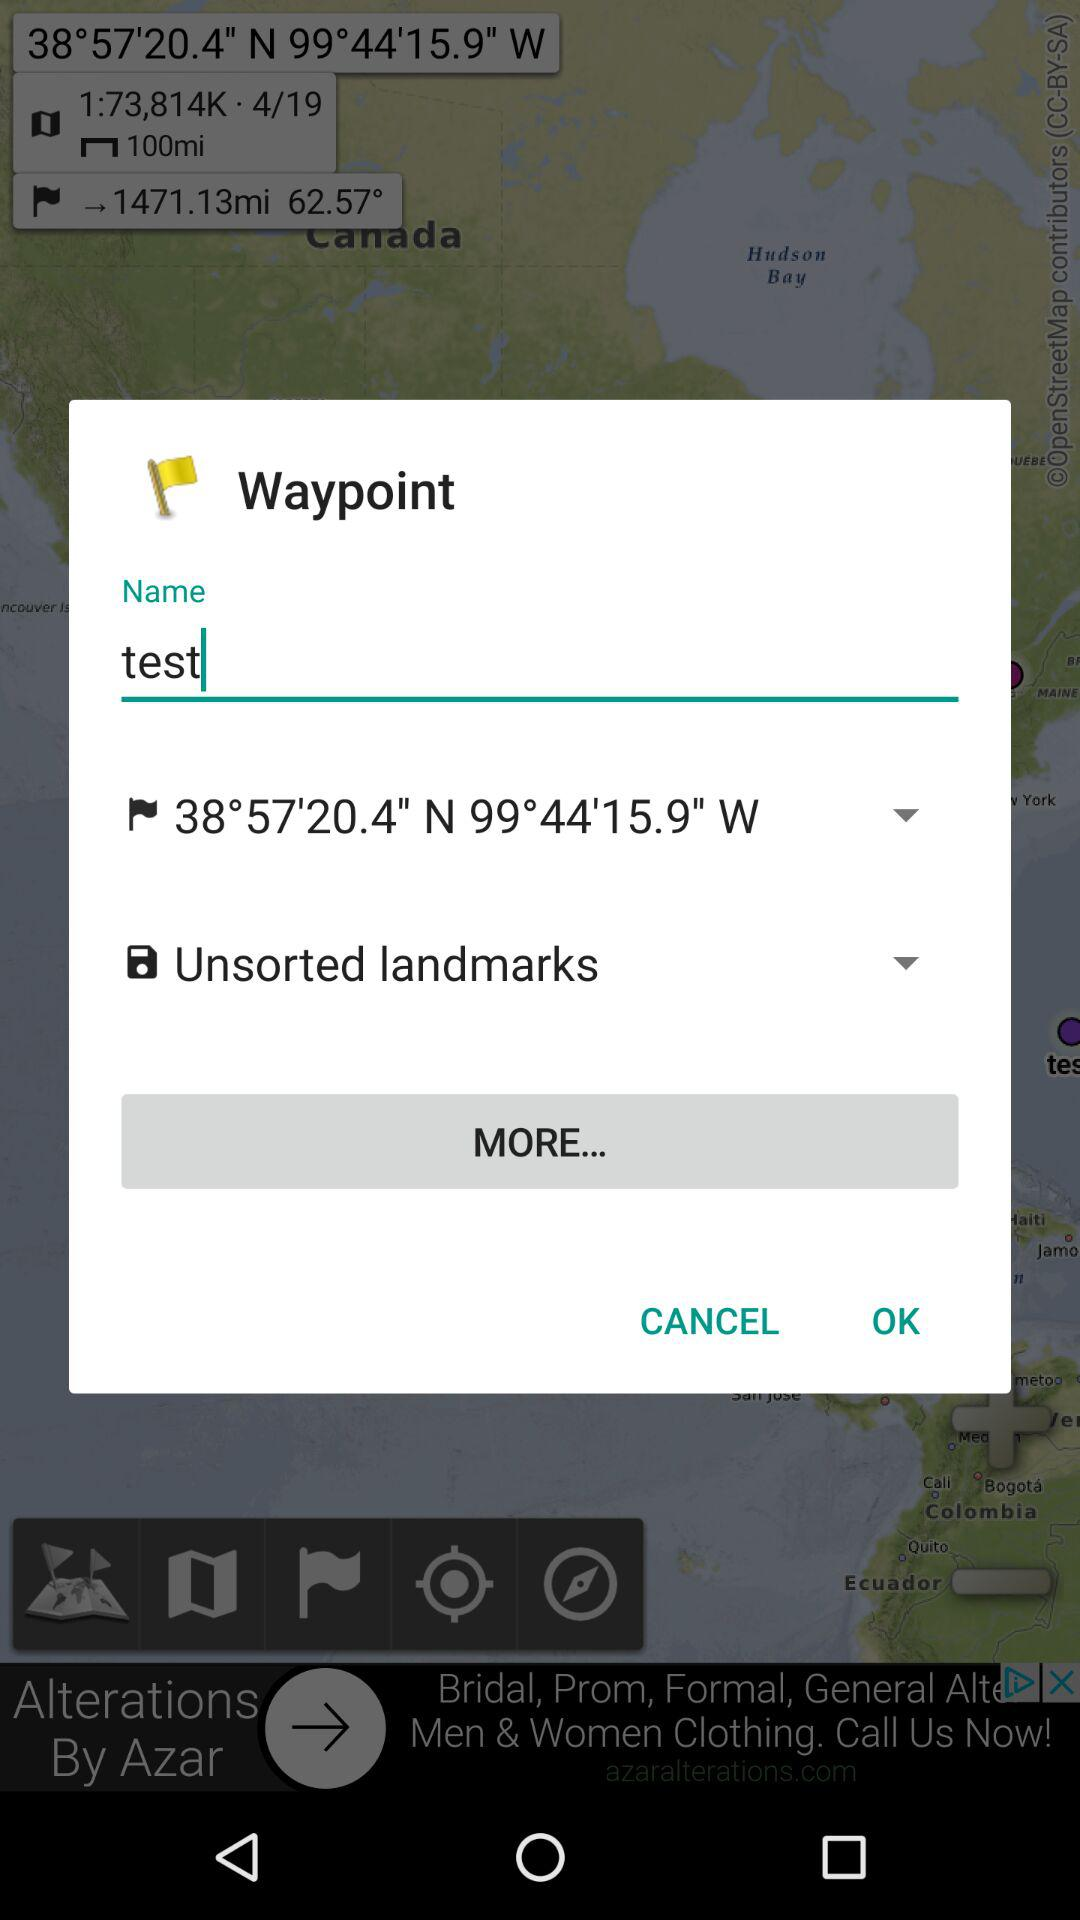What are the coordinates of north and west? The coordinates of north is 38°57'20.4" and the west is 99°44'15.9". 